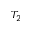Convert formula to latex. <formula><loc_0><loc_0><loc_500><loc_500>T _ { 2 }</formula> 